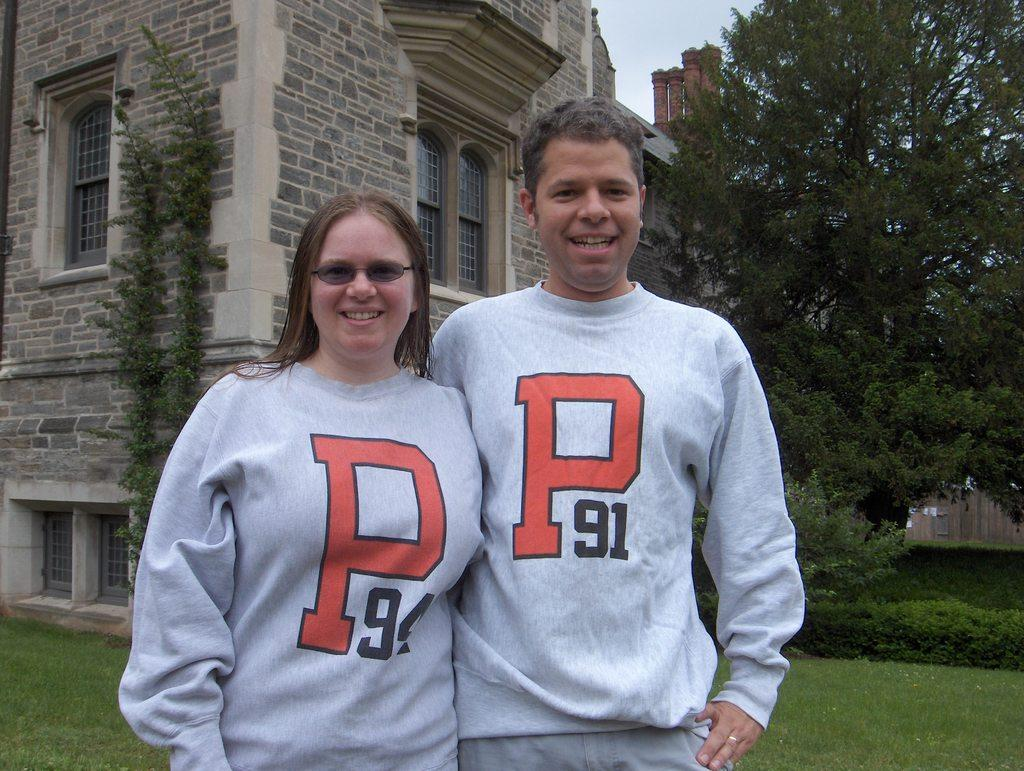<image>
Write a terse but informative summary of the picture. A woman and a man wearing matching sweaters that say, "P 91". 